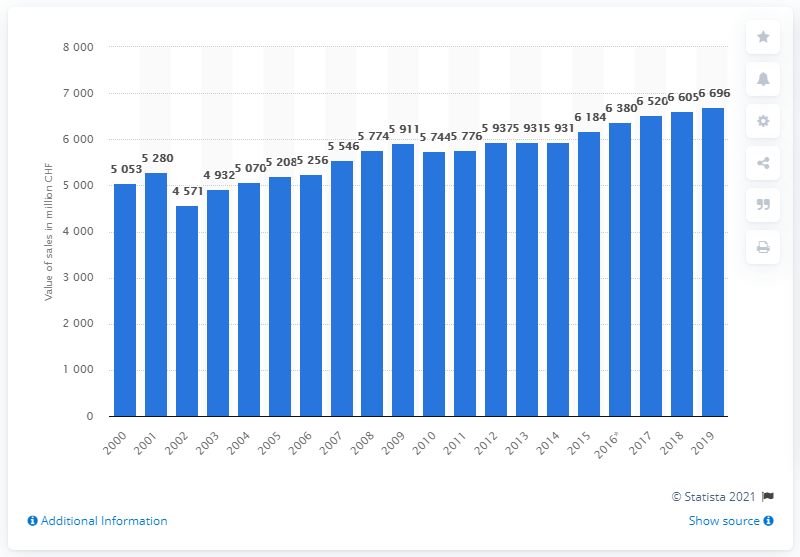Indicate a few pertinent items in this graphic. In 2019, the value of pharmaceutical sales in Switzerland was 6,696 million. 